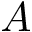Convert formula to latex. <formula><loc_0><loc_0><loc_500><loc_500>A</formula> 